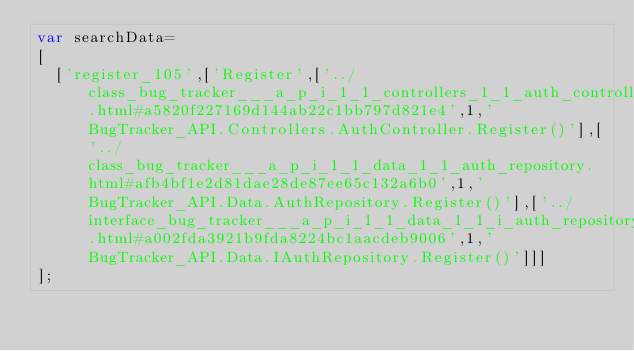Convert code to text. <code><loc_0><loc_0><loc_500><loc_500><_JavaScript_>var searchData=
[
  ['register_105',['Register',['../class_bug_tracker___a_p_i_1_1_controllers_1_1_auth_controller.html#a5820f227169d144ab22c1bb797d821e4',1,'BugTracker_API.Controllers.AuthController.Register()'],['../class_bug_tracker___a_p_i_1_1_data_1_1_auth_repository.html#afb4bf1e2d81dae28de87ee65c132a6b0',1,'BugTracker_API.Data.AuthRepository.Register()'],['../interface_bug_tracker___a_p_i_1_1_data_1_1_i_auth_repository.html#a002fda3921b9fda8224bc1aacdeb9006',1,'BugTracker_API.Data.IAuthRepository.Register()']]]
];
</code> 